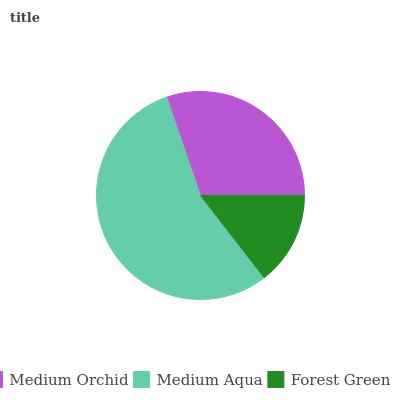Is Forest Green the minimum?
Answer yes or no. Yes. Is Medium Aqua the maximum?
Answer yes or no. Yes. Is Medium Aqua the minimum?
Answer yes or no. No. Is Forest Green the maximum?
Answer yes or no. No. Is Medium Aqua greater than Forest Green?
Answer yes or no. Yes. Is Forest Green less than Medium Aqua?
Answer yes or no. Yes. Is Forest Green greater than Medium Aqua?
Answer yes or no. No. Is Medium Aqua less than Forest Green?
Answer yes or no. No. Is Medium Orchid the high median?
Answer yes or no. Yes. Is Medium Orchid the low median?
Answer yes or no. Yes. Is Medium Aqua the high median?
Answer yes or no. No. Is Medium Aqua the low median?
Answer yes or no. No. 